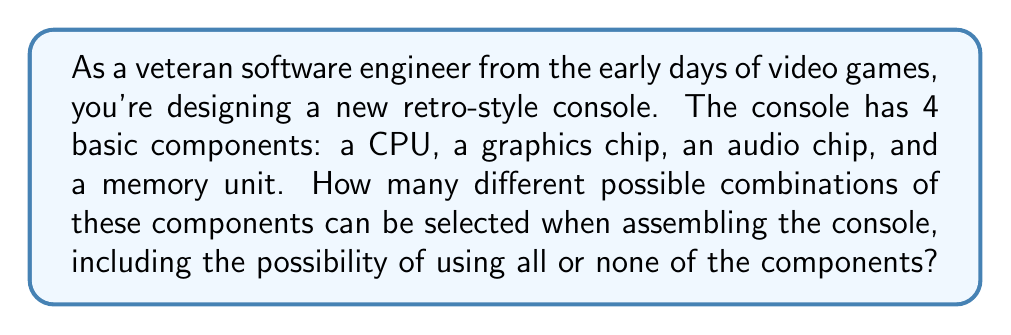What is the answer to this math problem? Let's approach this step-by-step:

1) First, recall that for a set with $n$ elements, the number of subsets (i.e., the cardinality of its power set) is $2^n$.

2) In this case, we have 4 components: CPU, graphics chip, audio chip, and memory unit. So, $n = 4$.

3) Each component can be either included or not included in a particular configuration. This is equivalent to finding all possible subsets of the set of components.

4) Therefore, we're looking for the cardinality of the power set of a 4-element set.

5) Using the formula:

   $$|\text{P}(S)| = 2^n = 2^4 = 16$$

6) We can verify this by listing all possibilities:
   - Empty set (no components)
   - 4 sets with 1 component each
   - 6 sets with 2 components each
   - 4 sets with 3 components each
   - 1 set with all 4 components

   Indeed, $1 + 4 + 6 + 4 + 1 = 16$

This result means there are 16 different ways to assemble the console, from using no components at all to using all four components.
Answer: $16$ possible combinations 